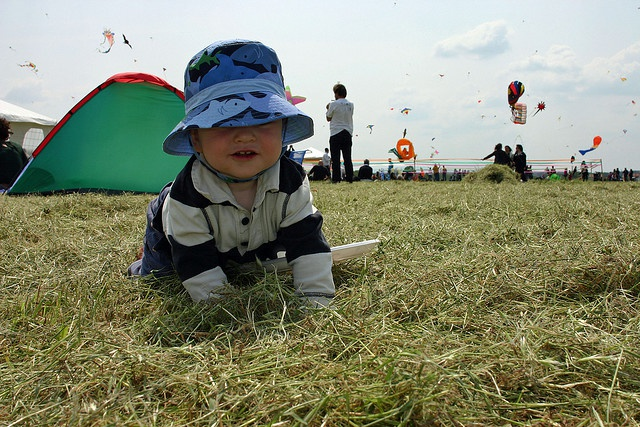Describe the objects in this image and their specific colors. I can see people in lightgray, black, gray, and maroon tones, kite in lightgray, darkgray, and lightpink tones, people in lightgray, black, gray, and darkgray tones, kite in lightgray, black, darkgray, and maroon tones, and kite in lightgray, red, and brown tones in this image. 